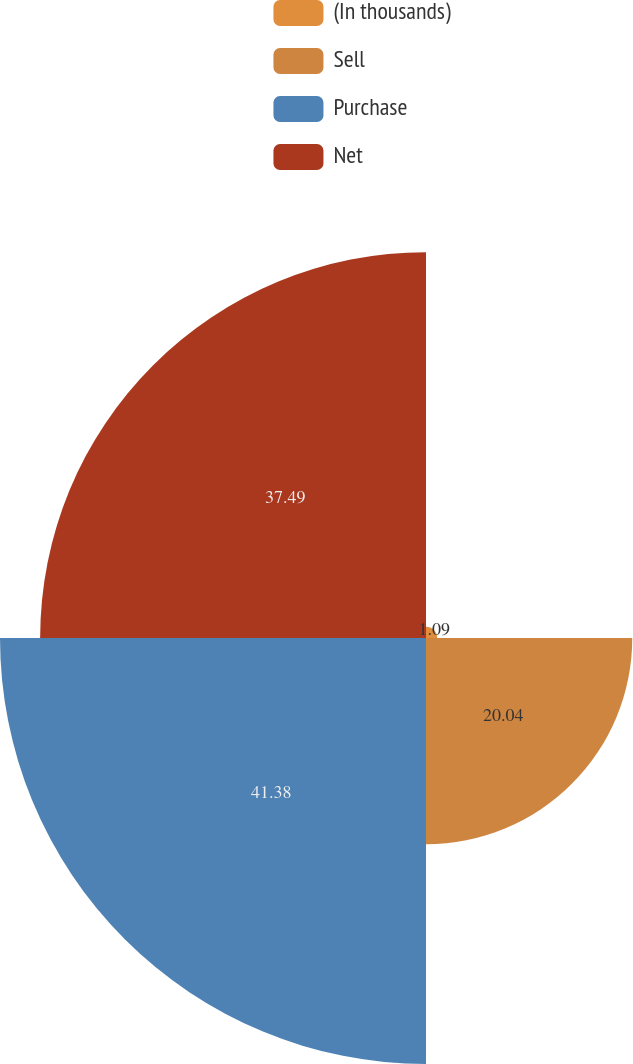<chart> <loc_0><loc_0><loc_500><loc_500><pie_chart><fcel>(In thousands)<fcel>Sell<fcel>Purchase<fcel>Net<nl><fcel>1.09%<fcel>20.04%<fcel>41.39%<fcel>37.49%<nl></chart> 